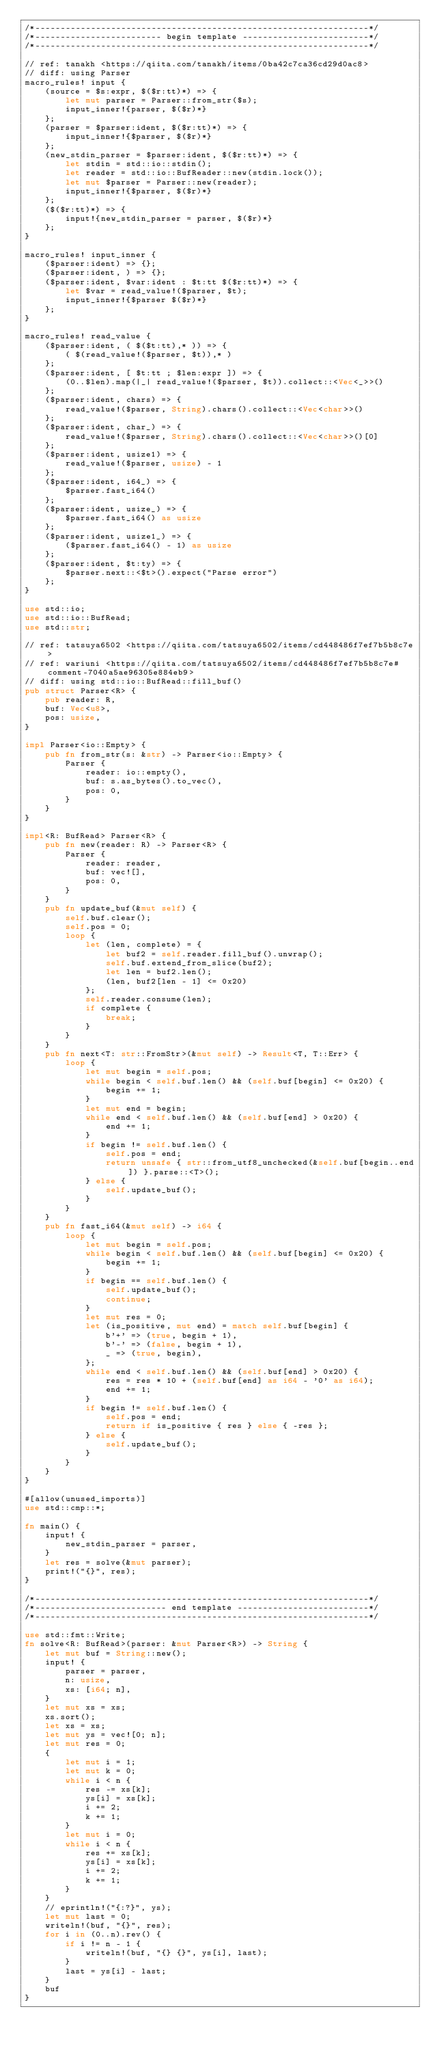<code> <loc_0><loc_0><loc_500><loc_500><_Rust_>/*------------------------------------------------------------------*/
/*------------------------- begin template -------------------------*/
/*------------------------------------------------------------------*/

// ref: tanakh <https://qiita.com/tanakh/items/0ba42c7ca36cd29d0ac8>
// diff: using Parser
macro_rules! input {
    (source = $s:expr, $($r:tt)*) => {
        let mut parser = Parser::from_str($s);
        input_inner!{parser, $($r)*}
    };
    (parser = $parser:ident, $($r:tt)*) => {
        input_inner!{$parser, $($r)*}
    };
    (new_stdin_parser = $parser:ident, $($r:tt)*) => {
        let stdin = std::io::stdin();
        let reader = std::io::BufReader::new(stdin.lock());
        let mut $parser = Parser::new(reader);
        input_inner!{$parser, $($r)*}
    };
    ($($r:tt)*) => {
        input!{new_stdin_parser = parser, $($r)*}
    };
}

macro_rules! input_inner {
    ($parser:ident) => {};
    ($parser:ident, ) => {};
    ($parser:ident, $var:ident : $t:tt $($r:tt)*) => {
        let $var = read_value!($parser, $t);
        input_inner!{$parser $($r)*}
    };
}

macro_rules! read_value {
    ($parser:ident, ( $($t:tt),* )) => {
        ( $(read_value!($parser, $t)),* )
    };
    ($parser:ident, [ $t:tt ; $len:expr ]) => {
        (0..$len).map(|_| read_value!($parser, $t)).collect::<Vec<_>>()
    };
    ($parser:ident, chars) => {
        read_value!($parser, String).chars().collect::<Vec<char>>()
    };
    ($parser:ident, char_) => {
        read_value!($parser, String).chars().collect::<Vec<char>>()[0]
    };
    ($parser:ident, usize1) => {
        read_value!($parser, usize) - 1
    };
    ($parser:ident, i64_) => {
        $parser.fast_i64()
    };
    ($parser:ident, usize_) => {
        $parser.fast_i64() as usize
    };
    ($parser:ident, usize1_) => {
        ($parser.fast_i64() - 1) as usize
    };
    ($parser:ident, $t:ty) => {
        $parser.next::<$t>().expect("Parse error")
    };
}

use std::io;
use std::io::BufRead;
use std::str;

// ref: tatsuya6502 <https://qiita.com/tatsuya6502/items/cd448486f7ef7b5b8c7e>
// ref: wariuni <https://qiita.com/tatsuya6502/items/cd448486f7ef7b5b8c7e#comment-7040a5ae96305e884eb9>
// diff: using std::io::BufRead::fill_buf()
pub struct Parser<R> {
    pub reader: R,
    buf: Vec<u8>,
    pos: usize,
}

impl Parser<io::Empty> {
    pub fn from_str(s: &str) -> Parser<io::Empty> {
        Parser {
            reader: io::empty(),
            buf: s.as_bytes().to_vec(),
            pos: 0,
        }
    }
}

impl<R: BufRead> Parser<R> {
    pub fn new(reader: R) -> Parser<R> {
        Parser {
            reader: reader,
            buf: vec![],
            pos: 0,
        }
    }
    pub fn update_buf(&mut self) {
        self.buf.clear();
        self.pos = 0;
        loop {
            let (len, complete) = {
                let buf2 = self.reader.fill_buf().unwrap();
                self.buf.extend_from_slice(buf2);
                let len = buf2.len();
                (len, buf2[len - 1] <= 0x20)
            };
            self.reader.consume(len);
            if complete {
                break;
            }
        }
    }
    pub fn next<T: str::FromStr>(&mut self) -> Result<T, T::Err> {
        loop {
            let mut begin = self.pos;
            while begin < self.buf.len() && (self.buf[begin] <= 0x20) {
                begin += 1;
            }
            let mut end = begin;
            while end < self.buf.len() && (self.buf[end] > 0x20) {
                end += 1;
            }
            if begin != self.buf.len() {
                self.pos = end;
                return unsafe { str::from_utf8_unchecked(&self.buf[begin..end]) }.parse::<T>();
            } else {
                self.update_buf();
            }
        }
    }
    pub fn fast_i64(&mut self) -> i64 {
        loop {
            let mut begin = self.pos;
            while begin < self.buf.len() && (self.buf[begin] <= 0x20) {
                begin += 1;
            }
            if begin == self.buf.len() {
                self.update_buf();
                continue;
            }
            let mut res = 0;
            let (is_positive, mut end) = match self.buf[begin] {
                b'+' => (true, begin + 1),
                b'-' => (false, begin + 1),
                _ => (true, begin),
            };
            while end < self.buf.len() && (self.buf[end] > 0x20) {
                res = res * 10 + (self.buf[end] as i64 - '0' as i64);
                end += 1;
            }
            if begin != self.buf.len() {
                self.pos = end;
                return if is_positive { res } else { -res };
            } else {
                self.update_buf();
            }
        }
    }
}

#[allow(unused_imports)]
use std::cmp::*;

fn main() {
    input! {
        new_stdin_parser = parser,
    }
    let res = solve(&mut parser);
    print!("{}", res);
}

/*------------------------------------------------------------------*/
/*-------------------------- end template --------------------------*/
/*------------------------------------------------------------------*/

use std::fmt::Write;
fn solve<R: BufRead>(parser: &mut Parser<R>) -> String {
    let mut buf = String::new();
    input! {
        parser = parser,
        n: usize,
        xs: [i64; n],
    }
    let mut xs = xs;
    xs.sort();
    let xs = xs;
    let mut ys = vec![0; n];
    let mut res = 0;
    {
        let mut i = 1;
        let mut k = 0;
        while i < n {
            res -= xs[k];
            ys[i] = xs[k];
            i += 2;
            k += 1;
        }
        let mut i = 0;
        while i < n {
            res += xs[k];
            ys[i] = xs[k];
            i += 2;
            k += 1;
        }
    }
    // eprintln!("{:?}", ys);
    let mut last = 0;
    writeln!(buf, "{}", res);
    for i in (0..n).rev() {
        if i != n - 1 {
            writeln!(buf, "{} {}", ys[i], last);
        }
        last = ys[i] - last;
    }
    buf
}
</code> 